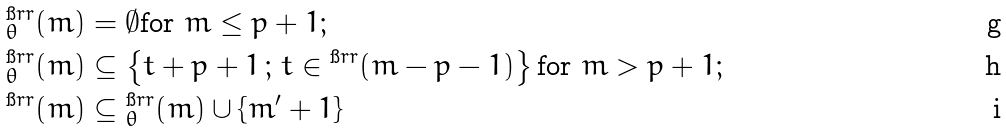Convert formula to latex. <formula><loc_0><loc_0><loc_500><loc_500>\L ^ { \i r r } _ { \theta } ( m ) & = \emptyset \text {for $m \leq p+1$} ; \\ \L ^ { \i r r } _ { \theta } ( m ) & \subseteq \left \{ t + p + 1 \, ; \, t \in \L ^ { \i r r } ( m - p - 1 ) \right \} \text {for $m > p+1$} ; \\ \L ^ { \i r r } ( m ) & \subseteq \L ^ { \i r r } _ { \theta } ( m ) \cup \{ m ^ { \prime } + 1 \}</formula> 